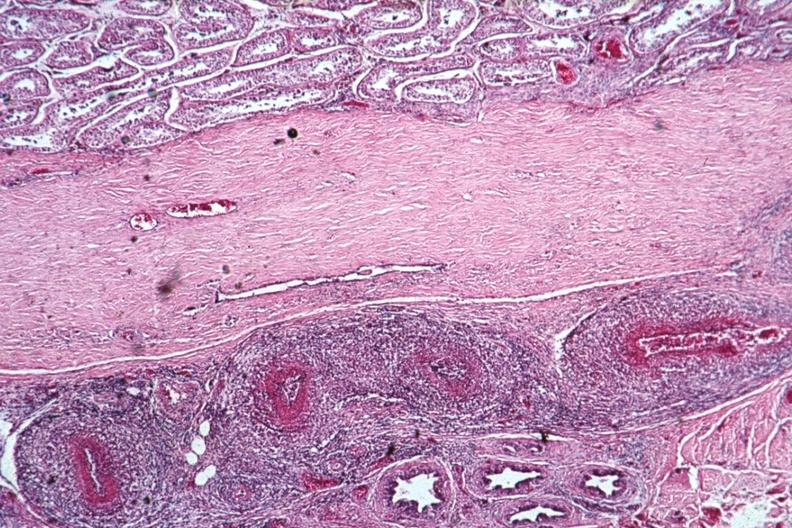s testicle present?
Answer the question using a single word or phrase. Yes 